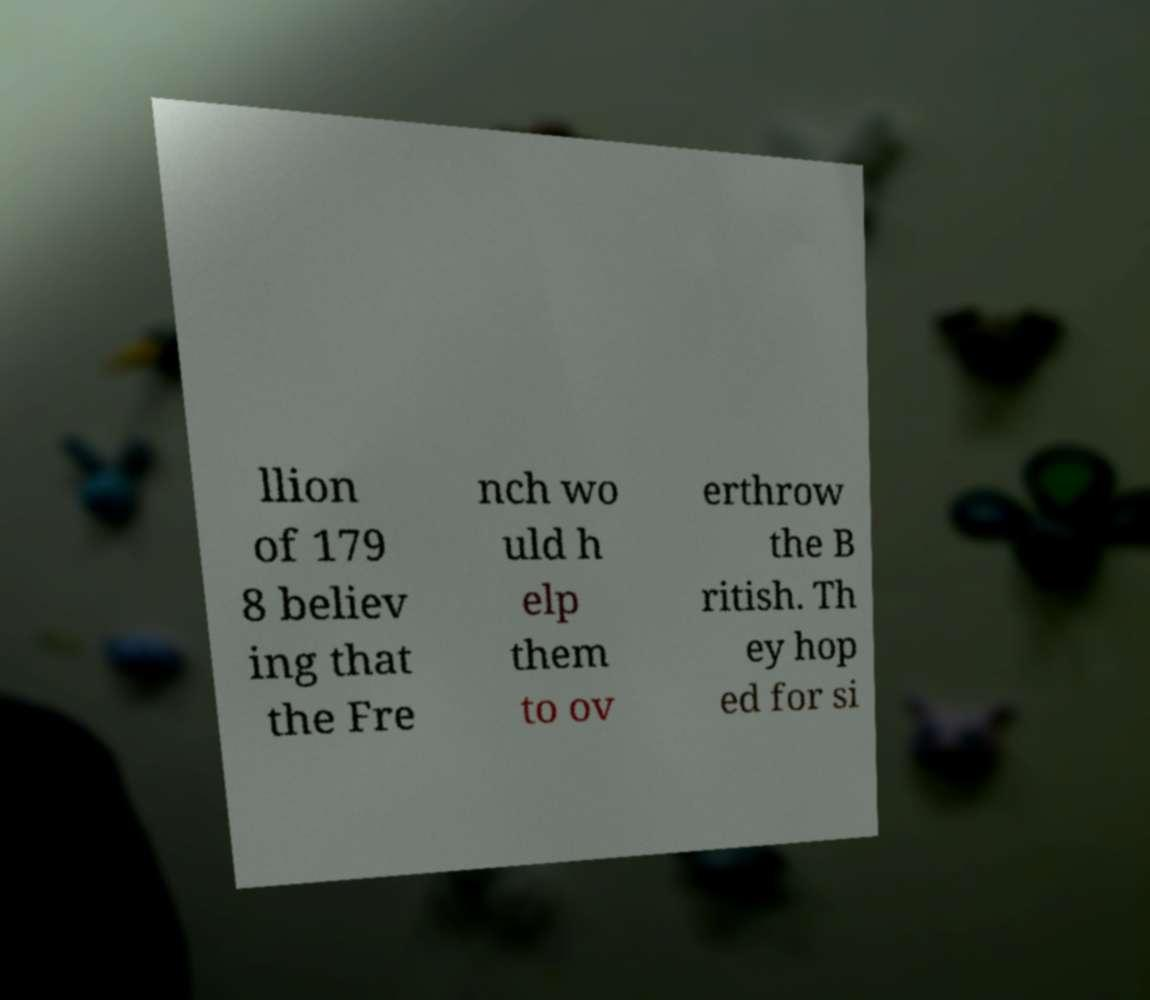Could you extract and type out the text from this image? llion of 179 8 believ ing that the Fre nch wo uld h elp them to ov erthrow the B ritish. Th ey hop ed for si 